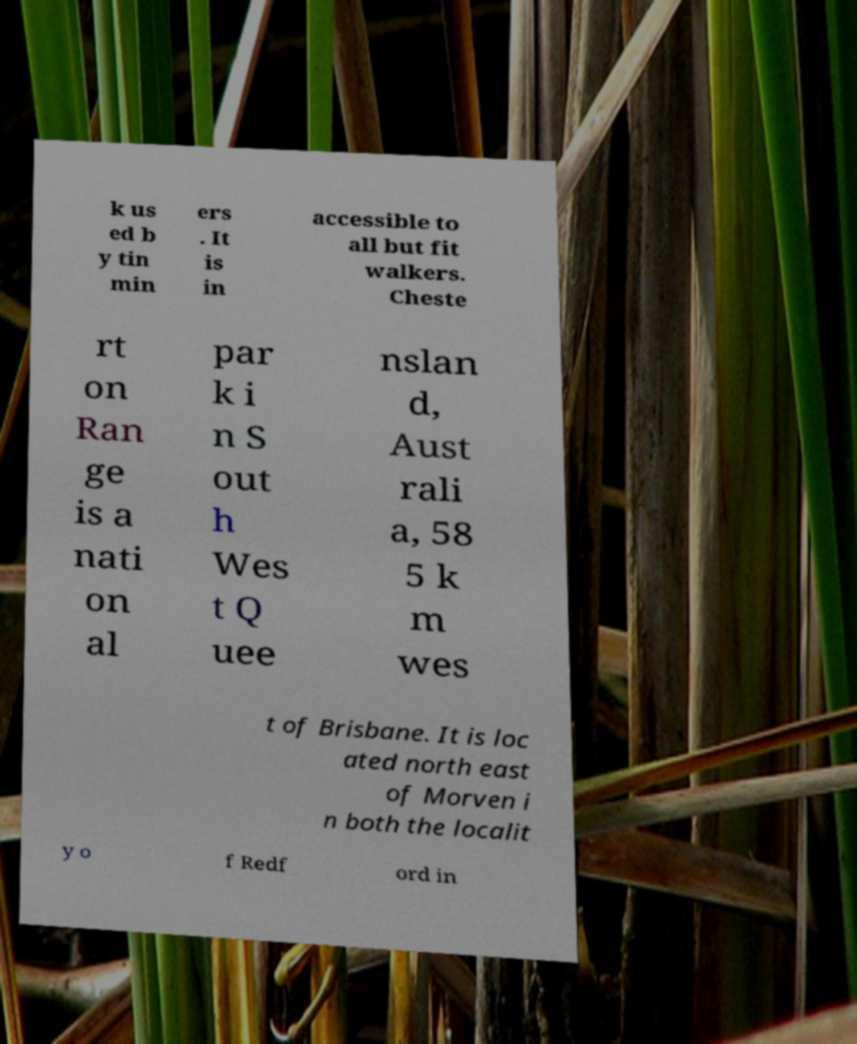Can you read and provide the text displayed in the image?This photo seems to have some interesting text. Can you extract and type it out for me? k us ed b y tin min ers . It is in accessible to all but fit walkers. Cheste rt on Ran ge is a nati on al par k i n S out h Wes t Q uee nslan d, Aust rali a, 58 5 k m wes t of Brisbane. It is loc ated north east of Morven i n both the localit y o f Redf ord in 